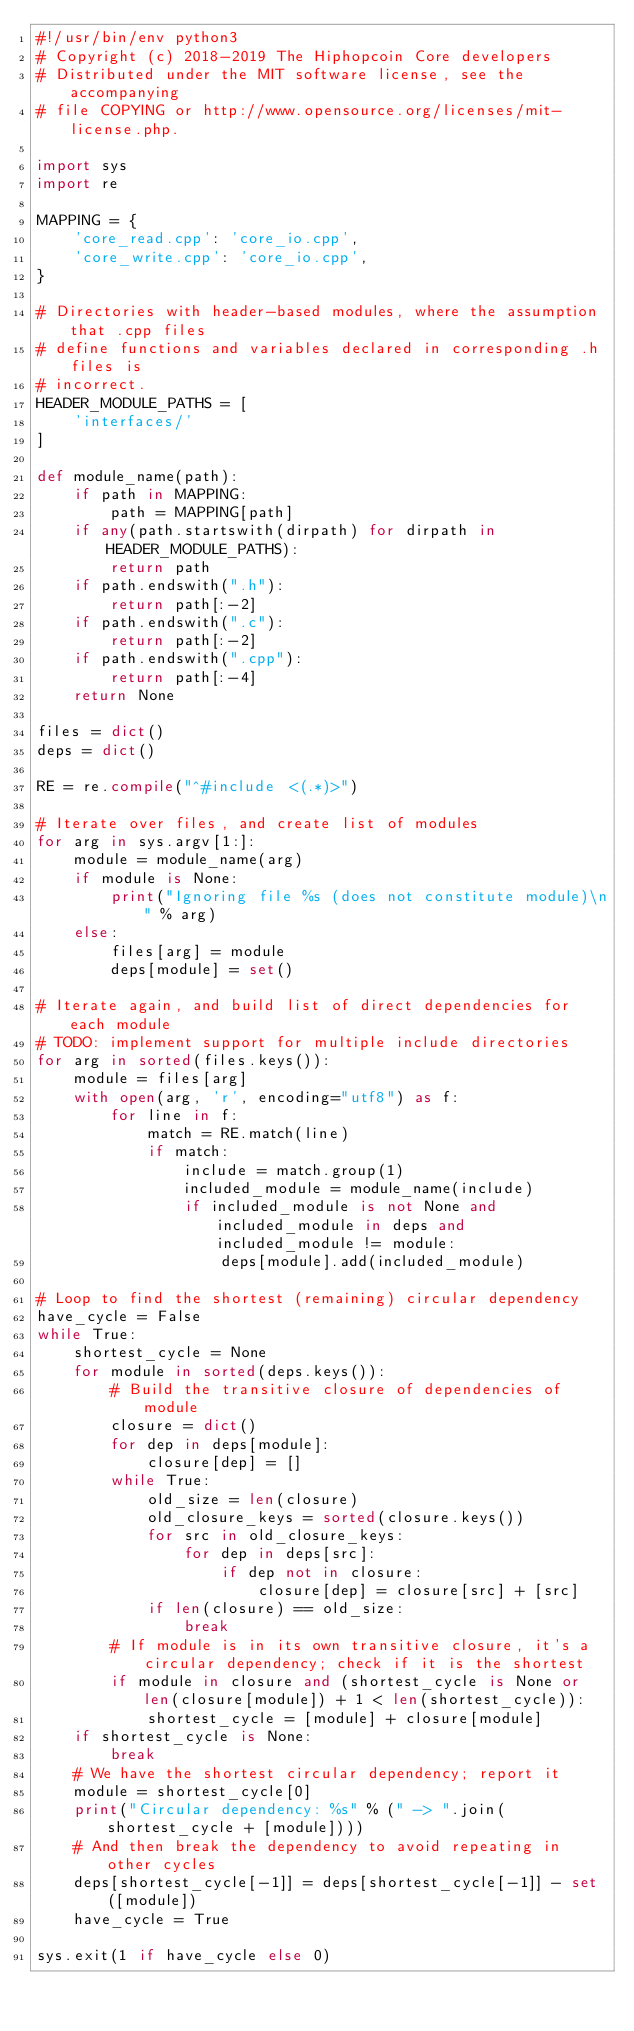<code> <loc_0><loc_0><loc_500><loc_500><_Python_>#!/usr/bin/env python3
# Copyright (c) 2018-2019 The Hiphopcoin Core developers
# Distributed under the MIT software license, see the accompanying
# file COPYING or http://www.opensource.org/licenses/mit-license.php.

import sys
import re

MAPPING = {
    'core_read.cpp': 'core_io.cpp',
    'core_write.cpp': 'core_io.cpp',
}

# Directories with header-based modules, where the assumption that .cpp files
# define functions and variables declared in corresponding .h files is
# incorrect.
HEADER_MODULE_PATHS = [
    'interfaces/'
]

def module_name(path):
    if path in MAPPING:
        path = MAPPING[path]
    if any(path.startswith(dirpath) for dirpath in HEADER_MODULE_PATHS):
        return path
    if path.endswith(".h"):
        return path[:-2]
    if path.endswith(".c"):
        return path[:-2]
    if path.endswith(".cpp"):
        return path[:-4]
    return None

files = dict()
deps = dict()

RE = re.compile("^#include <(.*)>")

# Iterate over files, and create list of modules
for arg in sys.argv[1:]:
    module = module_name(arg)
    if module is None:
        print("Ignoring file %s (does not constitute module)\n" % arg)
    else:
        files[arg] = module
        deps[module] = set()

# Iterate again, and build list of direct dependencies for each module
# TODO: implement support for multiple include directories
for arg in sorted(files.keys()):
    module = files[arg]
    with open(arg, 'r', encoding="utf8") as f:
        for line in f:
            match = RE.match(line)
            if match:
                include = match.group(1)
                included_module = module_name(include)
                if included_module is not None and included_module in deps and included_module != module:
                    deps[module].add(included_module)

# Loop to find the shortest (remaining) circular dependency
have_cycle = False
while True:
    shortest_cycle = None
    for module in sorted(deps.keys()):
        # Build the transitive closure of dependencies of module
        closure = dict()
        for dep in deps[module]:
            closure[dep] = []
        while True:
            old_size = len(closure)
            old_closure_keys = sorted(closure.keys())
            for src in old_closure_keys:
                for dep in deps[src]:
                    if dep not in closure:
                        closure[dep] = closure[src] + [src]
            if len(closure) == old_size:
                break
        # If module is in its own transitive closure, it's a circular dependency; check if it is the shortest
        if module in closure and (shortest_cycle is None or len(closure[module]) + 1 < len(shortest_cycle)):
            shortest_cycle = [module] + closure[module]
    if shortest_cycle is None:
        break
    # We have the shortest circular dependency; report it
    module = shortest_cycle[0]
    print("Circular dependency: %s" % (" -> ".join(shortest_cycle + [module])))
    # And then break the dependency to avoid repeating in other cycles
    deps[shortest_cycle[-1]] = deps[shortest_cycle[-1]] - set([module])
    have_cycle = True

sys.exit(1 if have_cycle else 0)
</code> 